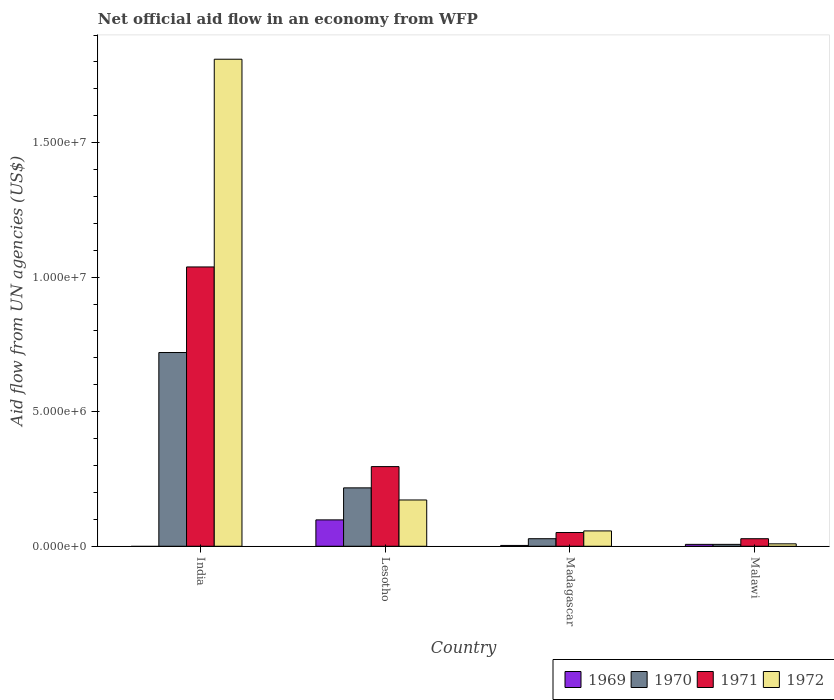How many different coloured bars are there?
Make the answer very short. 4. Are the number of bars per tick equal to the number of legend labels?
Offer a very short reply. No. What is the label of the 1st group of bars from the left?
Your answer should be compact. India. In how many cases, is the number of bars for a given country not equal to the number of legend labels?
Provide a short and direct response. 1. What is the net official aid flow in 1972 in Lesotho?
Your answer should be compact. 1.72e+06. Across all countries, what is the maximum net official aid flow in 1971?
Ensure brevity in your answer.  1.04e+07. What is the total net official aid flow in 1971 in the graph?
Give a very brief answer. 1.41e+07. What is the difference between the net official aid flow in 1969 in Lesotho and that in Malawi?
Provide a short and direct response. 9.10e+05. What is the difference between the net official aid flow in 1971 in Lesotho and the net official aid flow in 1972 in Malawi?
Provide a succinct answer. 2.87e+06. What is the average net official aid flow in 1972 per country?
Provide a succinct answer. 5.12e+06. What is the ratio of the net official aid flow in 1969 in Lesotho to that in Madagascar?
Ensure brevity in your answer.  32.67. Is the difference between the net official aid flow in 1970 in Lesotho and Madagascar greater than the difference between the net official aid flow in 1971 in Lesotho and Madagascar?
Your response must be concise. No. What is the difference between the highest and the second highest net official aid flow in 1969?
Offer a very short reply. 9.50e+05. What is the difference between the highest and the lowest net official aid flow in 1970?
Your response must be concise. 7.13e+06. In how many countries, is the net official aid flow in 1969 greater than the average net official aid flow in 1969 taken over all countries?
Your response must be concise. 1. Is it the case that in every country, the sum of the net official aid flow in 1970 and net official aid flow in 1972 is greater than the sum of net official aid flow in 1971 and net official aid flow in 1969?
Give a very brief answer. No. Is it the case that in every country, the sum of the net official aid flow in 1969 and net official aid flow in 1970 is greater than the net official aid flow in 1972?
Offer a very short reply. No. How many countries are there in the graph?
Ensure brevity in your answer.  4. Are the values on the major ticks of Y-axis written in scientific E-notation?
Give a very brief answer. Yes. Does the graph contain any zero values?
Offer a terse response. Yes. How many legend labels are there?
Offer a very short reply. 4. How are the legend labels stacked?
Your response must be concise. Horizontal. What is the title of the graph?
Your answer should be very brief. Net official aid flow in an economy from WFP. Does "1964" appear as one of the legend labels in the graph?
Keep it short and to the point. No. What is the label or title of the X-axis?
Your answer should be very brief. Country. What is the label or title of the Y-axis?
Your answer should be compact. Aid flow from UN agencies (US$). What is the Aid flow from UN agencies (US$) of 1970 in India?
Provide a succinct answer. 7.20e+06. What is the Aid flow from UN agencies (US$) of 1971 in India?
Keep it short and to the point. 1.04e+07. What is the Aid flow from UN agencies (US$) of 1972 in India?
Offer a very short reply. 1.81e+07. What is the Aid flow from UN agencies (US$) in 1969 in Lesotho?
Offer a very short reply. 9.80e+05. What is the Aid flow from UN agencies (US$) in 1970 in Lesotho?
Offer a terse response. 2.17e+06. What is the Aid flow from UN agencies (US$) of 1971 in Lesotho?
Your response must be concise. 2.96e+06. What is the Aid flow from UN agencies (US$) in 1972 in Lesotho?
Make the answer very short. 1.72e+06. What is the Aid flow from UN agencies (US$) in 1969 in Madagascar?
Your answer should be very brief. 3.00e+04. What is the Aid flow from UN agencies (US$) in 1971 in Madagascar?
Make the answer very short. 5.10e+05. What is the Aid flow from UN agencies (US$) of 1972 in Madagascar?
Provide a short and direct response. 5.70e+05. What is the Aid flow from UN agencies (US$) of 1970 in Malawi?
Ensure brevity in your answer.  7.00e+04. What is the Aid flow from UN agencies (US$) in 1971 in Malawi?
Make the answer very short. 2.80e+05. What is the Aid flow from UN agencies (US$) of 1972 in Malawi?
Offer a terse response. 9.00e+04. Across all countries, what is the maximum Aid flow from UN agencies (US$) of 1969?
Make the answer very short. 9.80e+05. Across all countries, what is the maximum Aid flow from UN agencies (US$) of 1970?
Make the answer very short. 7.20e+06. Across all countries, what is the maximum Aid flow from UN agencies (US$) in 1971?
Ensure brevity in your answer.  1.04e+07. Across all countries, what is the maximum Aid flow from UN agencies (US$) in 1972?
Keep it short and to the point. 1.81e+07. What is the total Aid flow from UN agencies (US$) in 1969 in the graph?
Your answer should be very brief. 1.08e+06. What is the total Aid flow from UN agencies (US$) in 1970 in the graph?
Ensure brevity in your answer.  9.72e+06. What is the total Aid flow from UN agencies (US$) of 1971 in the graph?
Provide a short and direct response. 1.41e+07. What is the total Aid flow from UN agencies (US$) of 1972 in the graph?
Make the answer very short. 2.05e+07. What is the difference between the Aid flow from UN agencies (US$) in 1970 in India and that in Lesotho?
Your response must be concise. 5.03e+06. What is the difference between the Aid flow from UN agencies (US$) in 1971 in India and that in Lesotho?
Offer a terse response. 7.42e+06. What is the difference between the Aid flow from UN agencies (US$) in 1972 in India and that in Lesotho?
Provide a succinct answer. 1.64e+07. What is the difference between the Aid flow from UN agencies (US$) of 1970 in India and that in Madagascar?
Your response must be concise. 6.92e+06. What is the difference between the Aid flow from UN agencies (US$) of 1971 in India and that in Madagascar?
Offer a terse response. 9.87e+06. What is the difference between the Aid flow from UN agencies (US$) in 1972 in India and that in Madagascar?
Keep it short and to the point. 1.75e+07. What is the difference between the Aid flow from UN agencies (US$) of 1970 in India and that in Malawi?
Give a very brief answer. 7.13e+06. What is the difference between the Aid flow from UN agencies (US$) in 1971 in India and that in Malawi?
Your answer should be very brief. 1.01e+07. What is the difference between the Aid flow from UN agencies (US$) of 1972 in India and that in Malawi?
Make the answer very short. 1.80e+07. What is the difference between the Aid flow from UN agencies (US$) in 1969 in Lesotho and that in Madagascar?
Give a very brief answer. 9.50e+05. What is the difference between the Aid flow from UN agencies (US$) in 1970 in Lesotho and that in Madagascar?
Make the answer very short. 1.89e+06. What is the difference between the Aid flow from UN agencies (US$) of 1971 in Lesotho and that in Madagascar?
Your answer should be compact. 2.45e+06. What is the difference between the Aid flow from UN agencies (US$) of 1972 in Lesotho and that in Madagascar?
Offer a terse response. 1.15e+06. What is the difference between the Aid flow from UN agencies (US$) of 1969 in Lesotho and that in Malawi?
Your response must be concise. 9.10e+05. What is the difference between the Aid flow from UN agencies (US$) in 1970 in Lesotho and that in Malawi?
Ensure brevity in your answer.  2.10e+06. What is the difference between the Aid flow from UN agencies (US$) in 1971 in Lesotho and that in Malawi?
Keep it short and to the point. 2.68e+06. What is the difference between the Aid flow from UN agencies (US$) in 1972 in Lesotho and that in Malawi?
Provide a short and direct response. 1.63e+06. What is the difference between the Aid flow from UN agencies (US$) in 1969 in Madagascar and that in Malawi?
Offer a very short reply. -4.00e+04. What is the difference between the Aid flow from UN agencies (US$) of 1971 in Madagascar and that in Malawi?
Give a very brief answer. 2.30e+05. What is the difference between the Aid flow from UN agencies (US$) in 1970 in India and the Aid flow from UN agencies (US$) in 1971 in Lesotho?
Offer a very short reply. 4.24e+06. What is the difference between the Aid flow from UN agencies (US$) in 1970 in India and the Aid flow from UN agencies (US$) in 1972 in Lesotho?
Provide a short and direct response. 5.48e+06. What is the difference between the Aid flow from UN agencies (US$) of 1971 in India and the Aid flow from UN agencies (US$) of 1972 in Lesotho?
Keep it short and to the point. 8.66e+06. What is the difference between the Aid flow from UN agencies (US$) in 1970 in India and the Aid flow from UN agencies (US$) in 1971 in Madagascar?
Make the answer very short. 6.69e+06. What is the difference between the Aid flow from UN agencies (US$) in 1970 in India and the Aid flow from UN agencies (US$) in 1972 in Madagascar?
Your response must be concise. 6.63e+06. What is the difference between the Aid flow from UN agencies (US$) of 1971 in India and the Aid flow from UN agencies (US$) of 1972 in Madagascar?
Your answer should be very brief. 9.81e+06. What is the difference between the Aid flow from UN agencies (US$) of 1970 in India and the Aid flow from UN agencies (US$) of 1971 in Malawi?
Offer a very short reply. 6.92e+06. What is the difference between the Aid flow from UN agencies (US$) in 1970 in India and the Aid flow from UN agencies (US$) in 1972 in Malawi?
Keep it short and to the point. 7.11e+06. What is the difference between the Aid flow from UN agencies (US$) of 1971 in India and the Aid flow from UN agencies (US$) of 1972 in Malawi?
Offer a terse response. 1.03e+07. What is the difference between the Aid flow from UN agencies (US$) in 1969 in Lesotho and the Aid flow from UN agencies (US$) in 1970 in Madagascar?
Offer a terse response. 7.00e+05. What is the difference between the Aid flow from UN agencies (US$) in 1969 in Lesotho and the Aid flow from UN agencies (US$) in 1971 in Madagascar?
Give a very brief answer. 4.70e+05. What is the difference between the Aid flow from UN agencies (US$) of 1969 in Lesotho and the Aid flow from UN agencies (US$) of 1972 in Madagascar?
Keep it short and to the point. 4.10e+05. What is the difference between the Aid flow from UN agencies (US$) in 1970 in Lesotho and the Aid flow from UN agencies (US$) in 1971 in Madagascar?
Make the answer very short. 1.66e+06. What is the difference between the Aid flow from UN agencies (US$) in 1970 in Lesotho and the Aid flow from UN agencies (US$) in 1972 in Madagascar?
Give a very brief answer. 1.60e+06. What is the difference between the Aid flow from UN agencies (US$) in 1971 in Lesotho and the Aid flow from UN agencies (US$) in 1972 in Madagascar?
Ensure brevity in your answer.  2.39e+06. What is the difference between the Aid flow from UN agencies (US$) in 1969 in Lesotho and the Aid flow from UN agencies (US$) in 1970 in Malawi?
Keep it short and to the point. 9.10e+05. What is the difference between the Aid flow from UN agencies (US$) in 1969 in Lesotho and the Aid flow from UN agencies (US$) in 1972 in Malawi?
Ensure brevity in your answer.  8.90e+05. What is the difference between the Aid flow from UN agencies (US$) of 1970 in Lesotho and the Aid flow from UN agencies (US$) of 1971 in Malawi?
Provide a succinct answer. 1.89e+06. What is the difference between the Aid flow from UN agencies (US$) of 1970 in Lesotho and the Aid flow from UN agencies (US$) of 1972 in Malawi?
Provide a succinct answer. 2.08e+06. What is the difference between the Aid flow from UN agencies (US$) in 1971 in Lesotho and the Aid flow from UN agencies (US$) in 1972 in Malawi?
Provide a short and direct response. 2.87e+06. What is the difference between the Aid flow from UN agencies (US$) in 1969 in Madagascar and the Aid flow from UN agencies (US$) in 1970 in Malawi?
Ensure brevity in your answer.  -4.00e+04. What is the difference between the Aid flow from UN agencies (US$) of 1969 in Madagascar and the Aid flow from UN agencies (US$) of 1971 in Malawi?
Ensure brevity in your answer.  -2.50e+05. What is the difference between the Aid flow from UN agencies (US$) in 1969 in Madagascar and the Aid flow from UN agencies (US$) in 1972 in Malawi?
Your answer should be compact. -6.00e+04. What is the difference between the Aid flow from UN agencies (US$) in 1970 in Madagascar and the Aid flow from UN agencies (US$) in 1971 in Malawi?
Offer a very short reply. 0. What is the difference between the Aid flow from UN agencies (US$) of 1971 in Madagascar and the Aid flow from UN agencies (US$) of 1972 in Malawi?
Your response must be concise. 4.20e+05. What is the average Aid flow from UN agencies (US$) in 1970 per country?
Make the answer very short. 2.43e+06. What is the average Aid flow from UN agencies (US$) of 1971 per country?
Offer a terse response. 3.53e+06. What is the average Aid flow from UN agencies (US$) of 1972 per country?
Your answer should be compact. 5.12e+06. What is the difference between the Aid flow from UN agencies (US$) of 1970 and Aid flow from UN agencies (US$) of 1971 in India?
Offer a terse response. -3.18e+06. What is the difference between the Aid flow from UN agencies (US$) of 1970 and Aid flow from UN agencies (US$) of 1972 in India?
Provide a short and direct response. -1.09e+07. What is the difference between the Aid flow from UN agencies (US$) in 1971 and Aid flow from UN agencies (US$) in 1972 in India?
Keep it short and to the point. -7.72e+06. What is the difference between the Aid flow from UN agencies (US$) in 1969 and Aid flow from UN agencies (US$) in 1970 in Lesotho?
Your answer should be very brief. -1.19e+06. What is the difference between the Aid flow from UN agencies (US$) in 1969 and Aid flow from UN agencies (US$) in 1971 in Lesotho?
Your answer should be very brief. -1.98e+06. What is the difference between the Aid flow from UN agencies (US$) of 1969 and Aid flow from UN agencies (US$) of 1972 in Lesotho?
Offer a very short reply. -7.40e+05. What is the difference between the Aid flow from UN agencies (US$) in 1970 and Aid flow from UN agencies (US$) in 1971 in Lesotho?
Offer a very short reply. -7.90e+05. What is the difference between the Aid flow from UN agencies (US$) of 1970 and Aid flow from UN agencies (US$) of 1972 in Lesotho?
Your response must be concise. 4.50e+05. What is the difference between the Aid flow from UN agencies (US$) in 1971 and Aid flow from UN agencies (US$) in 1972 in Lesotho?
Keep it short and to the point. 1.24e+06. What is the difference between the Aid flow from UN agencies (US$) of 1969 and Aid flow from UN agencies (US$) of 1970 in Madagascar?
Give a very brief answer. -2.50e+05. What is the difference between the Aid flow from UN agencies (US$) of 1969 and Aid flow from UN agencies (US$) of 1971 in Madagascar?
Your answer should be compact. -4.80e+05. What is the difference between the Aid flow from UN agencies (US$) in 1969 and Aid flow from UN agencies (US$) in 1972 in Madagascar?
Offer a very short reply. -5.40e+05. What is the difference between the Aid flow from UN agencies (US$) in 1970 and Aid flow from UN agencies (US$) in 1972 in Madagascar?
Provide a short and direct response. -2.90e+05. What is the difference between the Aid flow from UN agencies (US$) in 1969 and Aid flow from UN agencies (US$) in 1972 in Malawi?
Provide a short and direct response. -2.00e+04. What is the difference between the Aid flow from UN agencies (US$) of 1970 and Aid flow from UN agencies (US$) of 1972 in Malawi?
Offer a terse response. -2.00e+04. What is the ratio of the Aid flow from UN agencies (US$) in 1970 in India to that in Lesotho?
Provide a succinct answer. 3.32. What is the ratio of the Aid flow from UN agencies (US$) in 1971 in India to that in Lesotho?
Provide a succinct answer. 3.51. What is the ratio of the Aid flow from UN agencies (US$) of 1972 in India to that in Lesotho?
Ensure brevity in your answer.  10.52. What is the ratio of the Aid flow from UN agencies (US$) in 1970 in India to that in Madagascar?
Provide a succinct answer. 25.71. What is the ratio of the Aid flow from UN agencies (US$) in 1971 in India to that in Madagascar?
Provide a short and direct response. 20.35. What is the ratio of the Aid flow from UN agencies (US$) in 1972 in India to that in Madagascar?
Make the answer very short. 31.75. What is the ratio of the Aid flow from UN agencies (US$) in 1970 in India to that in Malawi?
Keep it short and to the point. 102.86. What is the ratio of the Aid flow from UN agencies (US$) in 1971 in India to that in Malawi?
Your answer should be compact. 37.07. What is the ratio of the Aid flow from UN agencies (US$) of 1972 in India to that in Malawi?
Your answer should be very brief. 201.11. What is the ratio of the Aid flow from UN agencies (US$) of 1969 in Lesotho to that in Madagascar?
Ensure brevity in your answer.  32.67. What is the ratio of the Aid flow from UN agencies (US$) in 1970 in Lesotho to that in Madagascar?
Provide a succinct answer. 7.75. What is the ratio of the Aid flow from UN agencies (US$) in 1971 in Lesotho to that in Madagascar?
Offer a terse response. 5.8. What is the ratio of the Aid flow from UN agencies (US$) in 1972 in Lesotho to that in Madagascar?
Offer a very short reply. 3.02. What is the ratio of the Aid flow from UN agencies (US$) in 1970 in Lesotho to that in Malawi?
Provide a succinct answer. 31. What is the ratio of the Aid flow from UN agencies (US$) in 1971 in Lesotho to that in Malawi?
Ensure brevity in your answer.  10.57. What is the ratio of the Aid flow from UN agencies (US$) in 1972 in Lesotho to that in Malawi?
Ensure brevity in your answer.  19.11. What is the ratio of the Aid flow from UN agencies (US$) in 1969 in Madagascar to that in Malawi?
Make the answer very short. 0.43. What is the ratio of the Aid flow from UN agencies (US$) in 1971 in Madagascar to that in Malawi?
Offer a very short reply. 1.82. What is the ratio of the Aid flow from UN agencies (US$) of 1972 in Madagascar to that in Malawi?
Offer a terse response. 6.33. What is the difference between the highest and the second highest Aid flow from UN agencies (US$) in 1969?
Offer a very short reply. 9.10e+05. What is the difference between the highest and the second highest Aid flow from UN agencies (US$) of 1970?
Make the answer very short. 5.03e+06. What is the difference between the highest and the second highest Aid flow from UN agencies (US$) of 1971?
Provide a short and direct response. 7.42e+06. What is the difference between the highest and the second highest Aid flow from UN agencies (US$) in 1972?
Your response must be concise. 1.64e+07. What is the difference between the highest and the lowest Aid flow from UN agencies (US$) of 1969?
Provide a succinct answer. 9.80e+05. What is the difference between the highest and the lowest Aid flow from UN agencies (US$) of 1970?
Your answer should be very brief. 7.13e+06. What is the difference between the highest and the lowest Aid flow from UN agencies (US$) of 1971?
Offer a terse response. 1.01e+07. What is the difference between the highest and the lowest Aid flow from UN agencies (US$) in 1972?
Ensure brevity in your answer.  1.80e+07. 